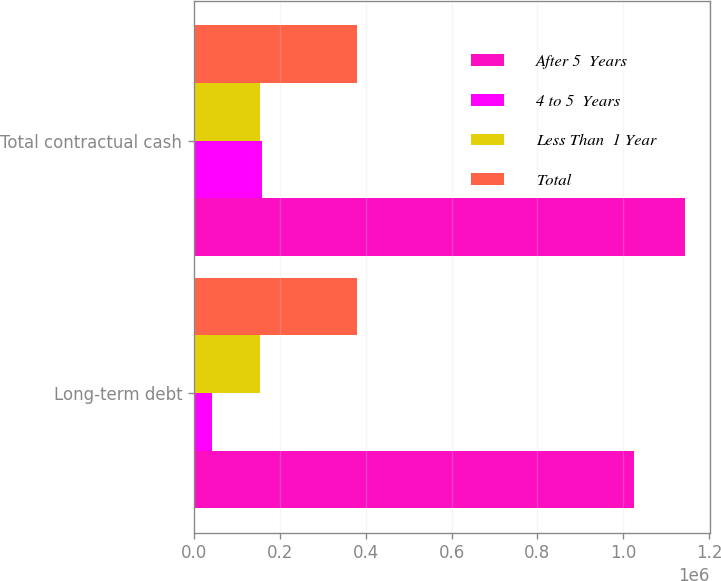Convert chart to OTSL. <chart><loc_0><loc_0><loc_500><loc_500><stacked_bar_chart><ecel><fcel>Long-term debt<fcel>Total contractual cash<nl><fcel>After 5  Years<fcel>1.02525e+06<fcel>1.14346e+06<nl><fcel>4 to 5  Years<fcel>41919<fcel>158330<nl><fcel>Less Than  1 Year<fcel>153327<fcel>155127<nl><fcel>Total<fcel>380000<fcel>380000<nl></chart> 